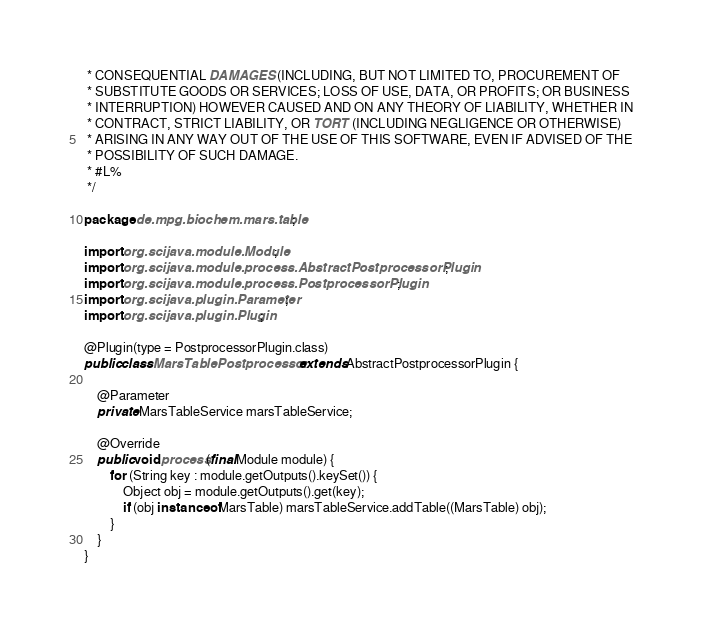<code> <loc_0><loc_0><loc_500><loc_500><_Java_> * CONSEQUENTIAL DAMAGES (INCLUDING, BUT NOT LIMITED TO, PROCUREMENT OF
 * SUBSTITUTE GOODS OR SERVICES; LOSS OF USE, DATA, OR PROFITS; OR BUSINESS
 * INTERRUPTION) HOWEVER CAUSED AND ON ANY THEORY OF LIABILITY, WHETHER IN
 * CONTRACT, STRICT LIABILITY, OR TORT (INCLUDING NEGLIGENCE OR OTHERWISE)
 * ARISING IN ANY WAY OUT OF THE USE OF THIS SOFTWARE, EVEN IF ADVISED OF THE
 * POSSIBILITY OF SUCH DAMAGE.
 * #L%
 */

package de.mpg.biochem.mars.table;

import org.scijava.module.Module;
import org.scijava.module.process.AbstractPostprocessorPlugin;
import org.scijava.module.process.PostprocessorPlugin;
import org.scijava.plugin.Parameter;
import org.scijava.plugin.Plugin;

@Plugin(type = PostprocessorPlugin.class)
public class MarsTablePostprocessor extends AbstractPostprocessorPlugin {

	@Parameter
	private MarsTableService marsTableService;

	@Override
	public void process(final Module module) {
		for (String key : module.getOutputs().keySet()) {
			Object obj = module.getOutputs().get(key);
			if (obj instanceof MarsTable) marsTableService.addTable((MarsTable) obj);
		}
	}
}
</code> 